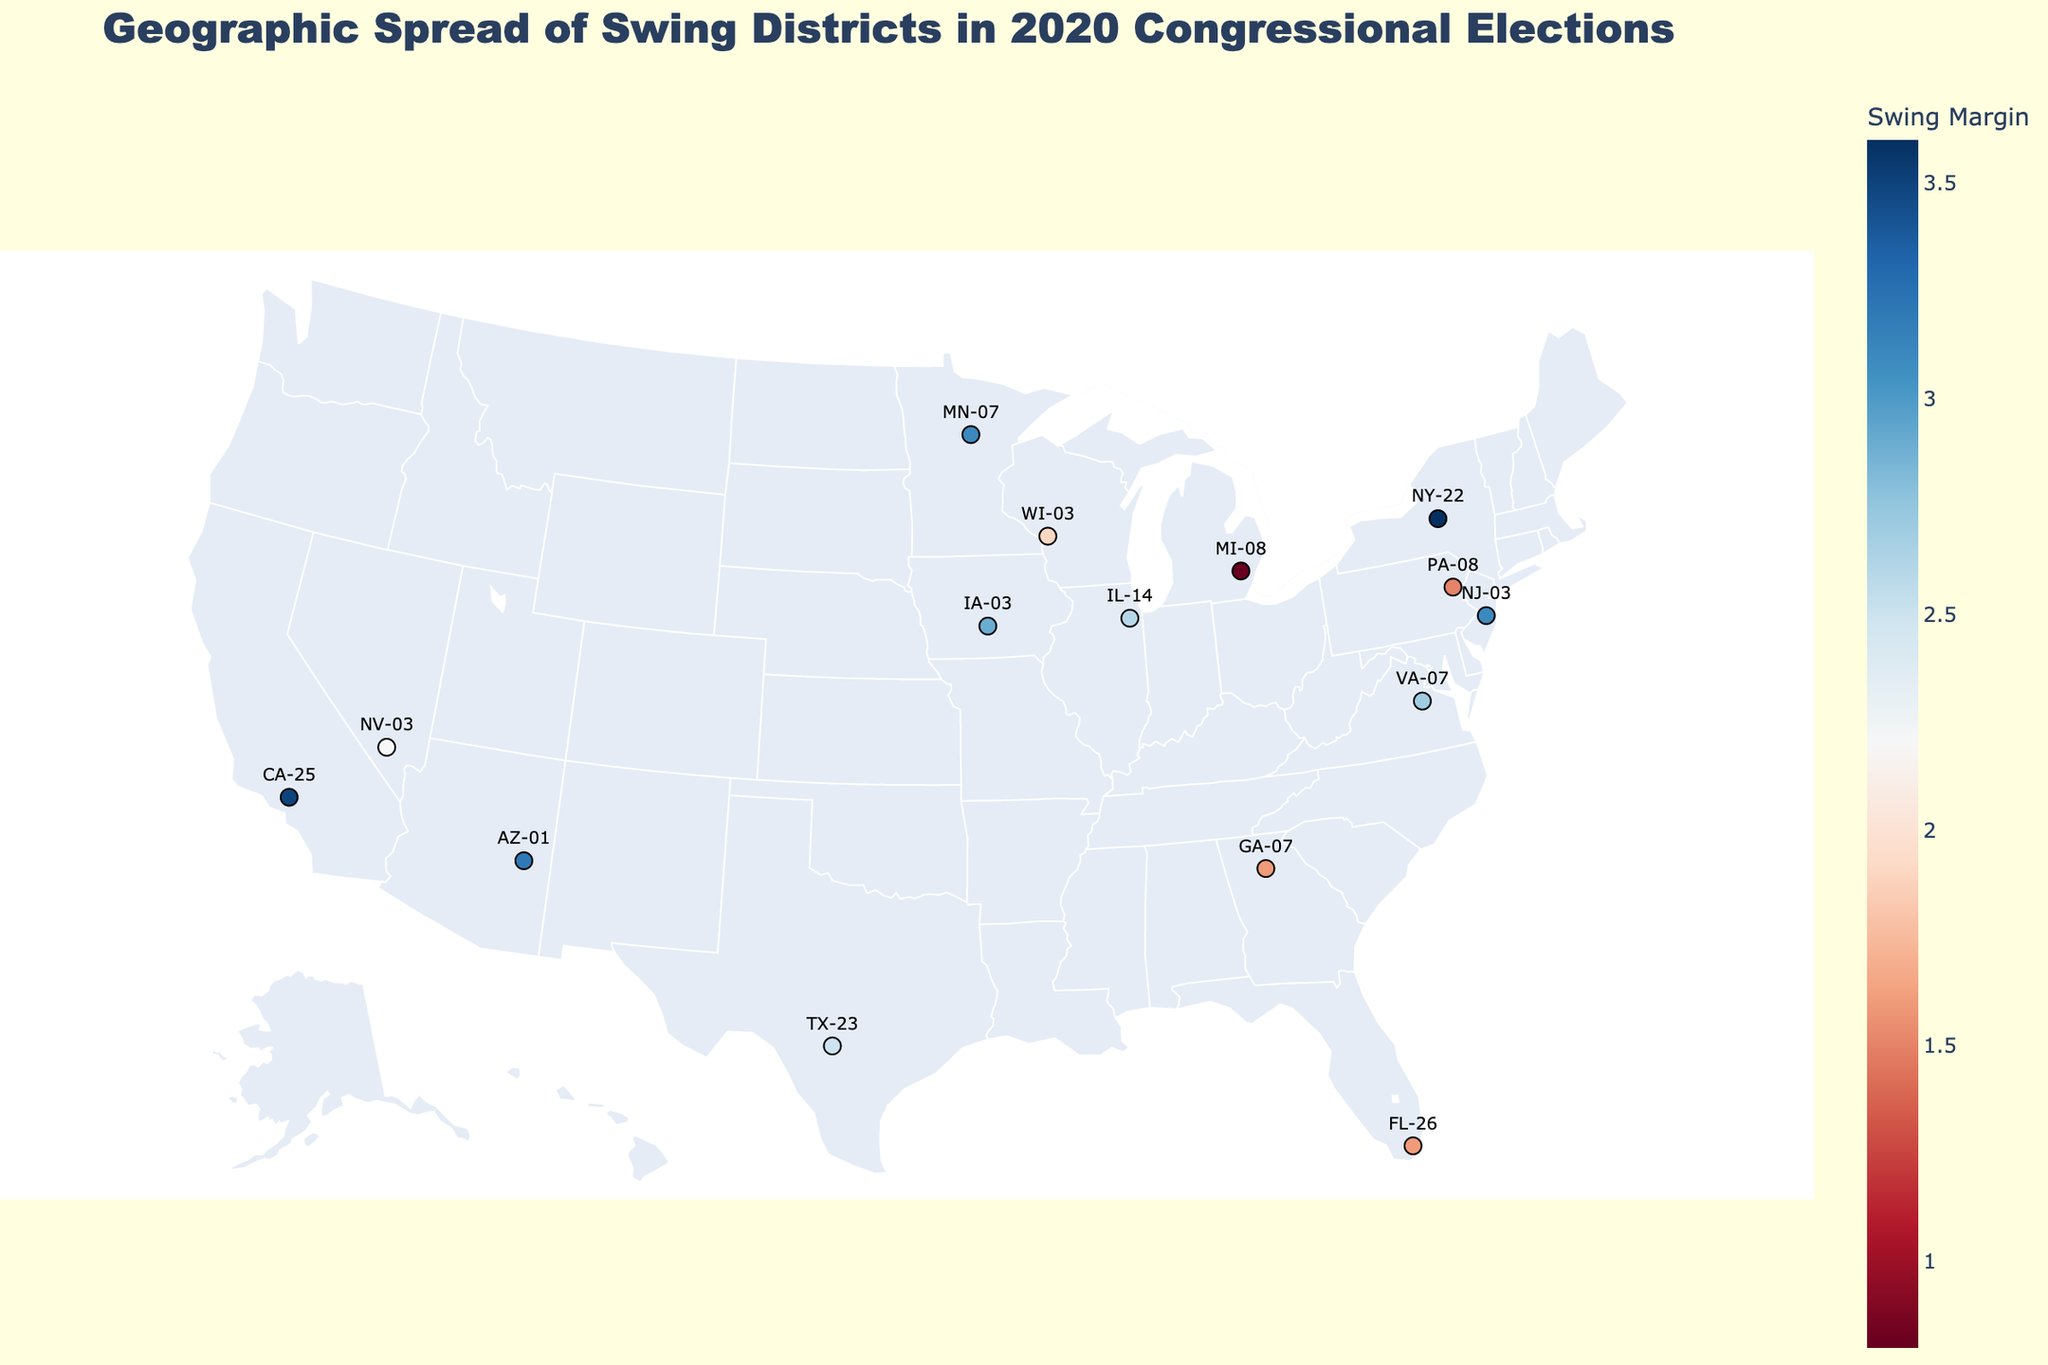What's the title of the figure? The figure's title is seen at the top and is meant to give a summary of what the plot represents. You can read it directly from there.
Answer: Geographic Spread of Swing Districts in 2020 Congressional Elections Which state has the district with the smallest swing margin? By looking at the color scale and reading the labels, New York (NY-22) has the district with the smallest swing margin of 0.8%.
Answer: New York Which party won the Texas swing district? Click on the Texas marker on the map and look at the attached tooltip text. It will indicate that the Republican Party won in Texas (TX-23).
Answer: Republican What is the average swing margin of all the districts? You add all the swing margin percentages of the districts and divide by the number of districts (15). (1.2+2.8+1.5+3.6+1.3+2.2+0.8+2.9+1.9+1.7+2.5+2.8+0.9+1.3+1.8)/15 ≈ 1.93.
Answer: 1.93 How many districts were won by the Democratic Party? Click on each district marker and check the tooltip text for the winning party. Count the number where it says "Winner: Democratic".
Answer: 9 Which state’s swing district had the highest margin and what is it? Look at the color intensity and hover over the district markers. Michigan (MI-08) has the highest swing margin at 3.6%.
Answer: Michigan, 3.6% Are there more swing districts won by Republicans or Democrats? Compare the total numbers of districts won by each party by clicking on each marker. Democrats have 9 wins, and Republicans have 6 wins.
Answer: Democrats Which region (East, West, Midwest, South) has the most swing districts? By looking at the spread of the districts on the map, identify which region has the higher concentration of marked districts. The East has the most districts.
Answer: East Compare the swing margins between IA-03 and CA-25. Which one has a smaller margin? Hover over the IA-03 marker and CA-25 marker. IA-03 has a swing margin of 1.5% while CA-25 has a swing margin of 0.9%, making CA-25 smaller.
Answer: CA-25 What color scale is used for representing the swing margin? By glancing at the color key legend on the side of the map, you can see that a blue-red color scale is employed (RdBu in natural language).
Answer: Blue-Red 